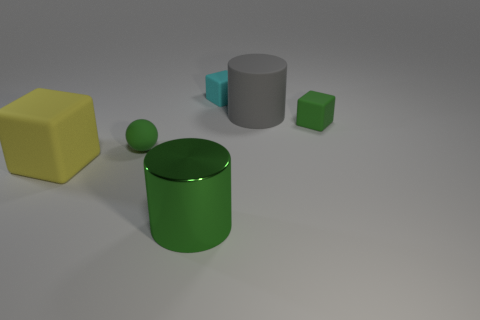Subtract all cyan cubes. How many cubes are left? 2 Add 3 large rubber blocks. How many objects exist? 9 Subtract all spheres. How many objects are left? 5 Subtract all cyan blocks. How many blocks are left? 2 Subtract all green cylinders. Subtract all blue balls. How many cylinders are left? 1 Subtract all small green balls. Subtract all gray matte things. How many objects are left? 4 Add 4 tiny green objects. How many tiny green objects are left? 6 Add 3 yellow things. How many yellow things exist? 4 Subtract 1 yellow cubes. How many objects are left? 5 